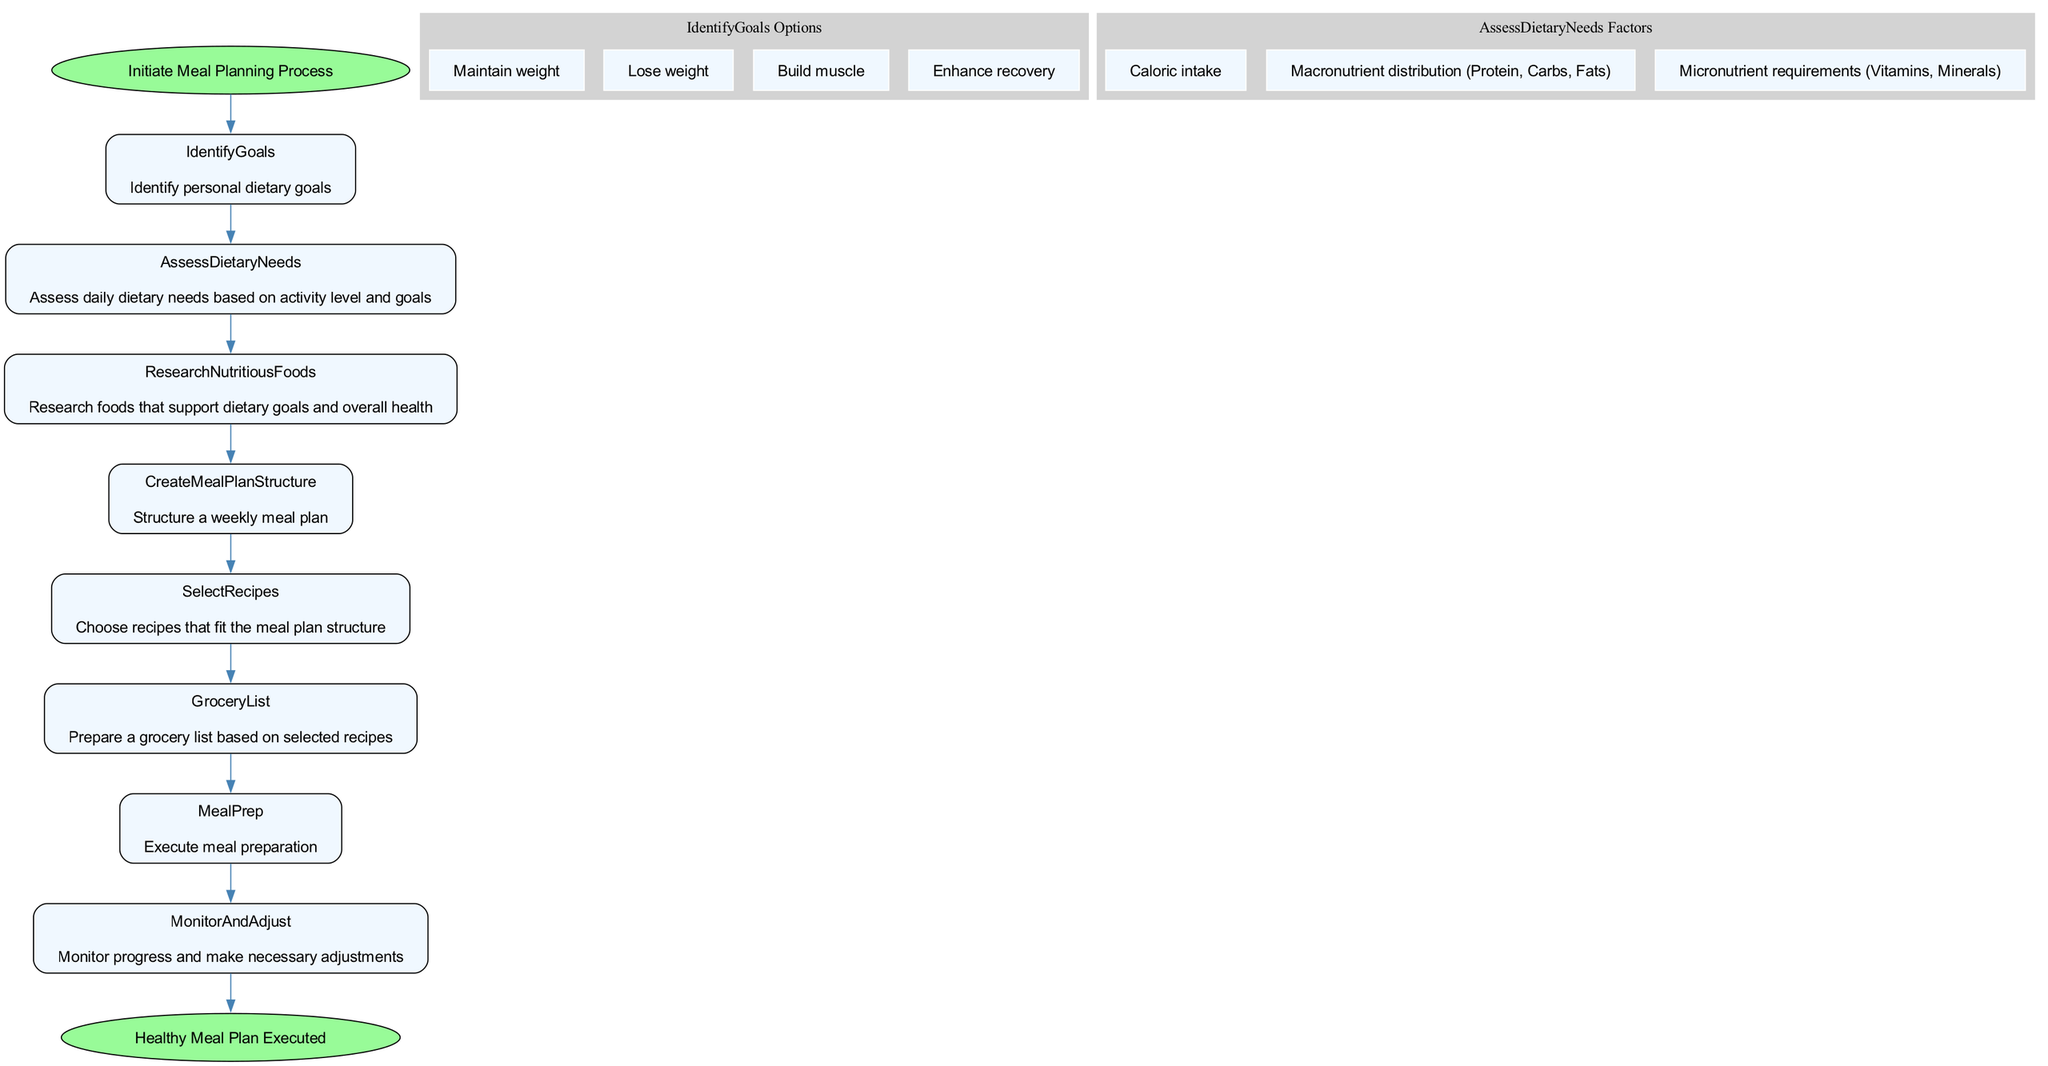What is the starting point of the flowchart? The starting point of the flowchart is "Initiate Meal Planning Process," which indicates the first step in the meal planning process.
Answer: Initiate Meal Planning Process How many main steps are in the diagram? The main steps, excluding the start and end, include: Identify Goals, Assess Dietary Needs, Research Nutritious Foods, Create Meal Plan Structure, Select Recipes, Grocery List, Meal Prep, and Monitor and Adjust, totaling to eight steps.
Answer: 8 What is one of the factors assessed in dietary needs? One of the factors assessed in dietary needs is "Caloric intake," which is essential for understanding how many calories are needed daily.
Answer: Caloric intake Which node follows the Research Nutritious Foods step? The node that follows the Research Nutritious Foods step is the Create Meal Plan Structure step, indicating that after researching nutritious foods, the next action is structuring the meal plan.
Answer: Create Meal Plan Structure What are the total meals planned per day in the structure? The total meals planned per day in the structure is three, as indicated in the meal plan structure description.
Answer: 3 List one criterion for selecting recipes. One criterion for selecting recipes is "Balance of macronutrients," which refers to ensuring that the meals contain an appropriate mix of proteins, fats, and carbohydrates.
Answer: Balance of macronutrients What is the final step in the meal planning process? The final step in the meal planning process, as indicated in the flowchart, is "Healthy Meal Plan Executed," which denotes the conclusion of the meal planning process.
Answer: Healthy Meal Plan Executed How are grocery items prepared according to the selected recipes? Grocery items are prepared for purchasing through the creation of a grocery list that includes various food categories such as lean proteins and fresh produce.
Answer: Grocery list 